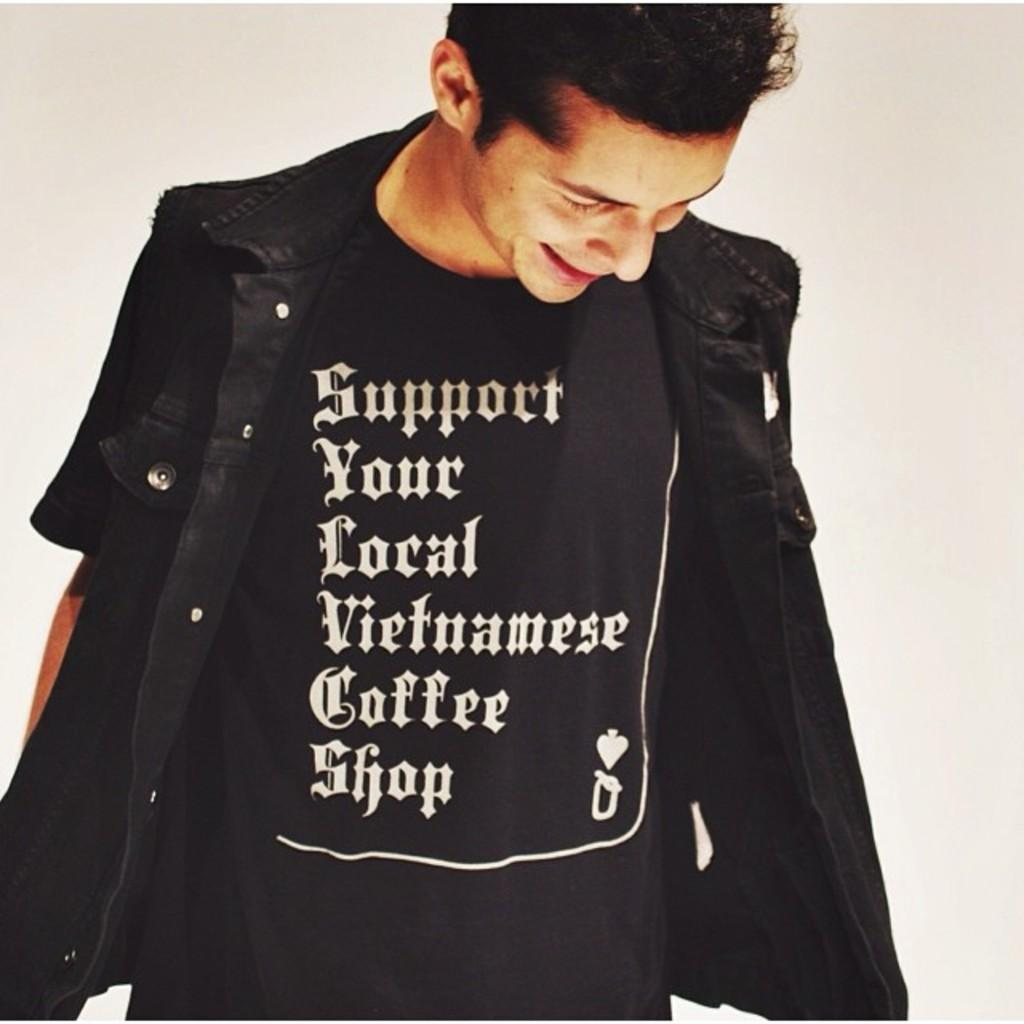What is the main subject of the picture? The main subject of the picture is a man standing. What can be seen in the background of the image? The background of the image is white. What is the man wearing that has text on it? The man is wearing a t-shirt with text on it. Can you tell me what type of receipt is on the man's head in the image? There is no receipt present on the man's head in the image. What kind of lamp is hanging above the man in the image? There is no lamp present in the image; the background is white. 